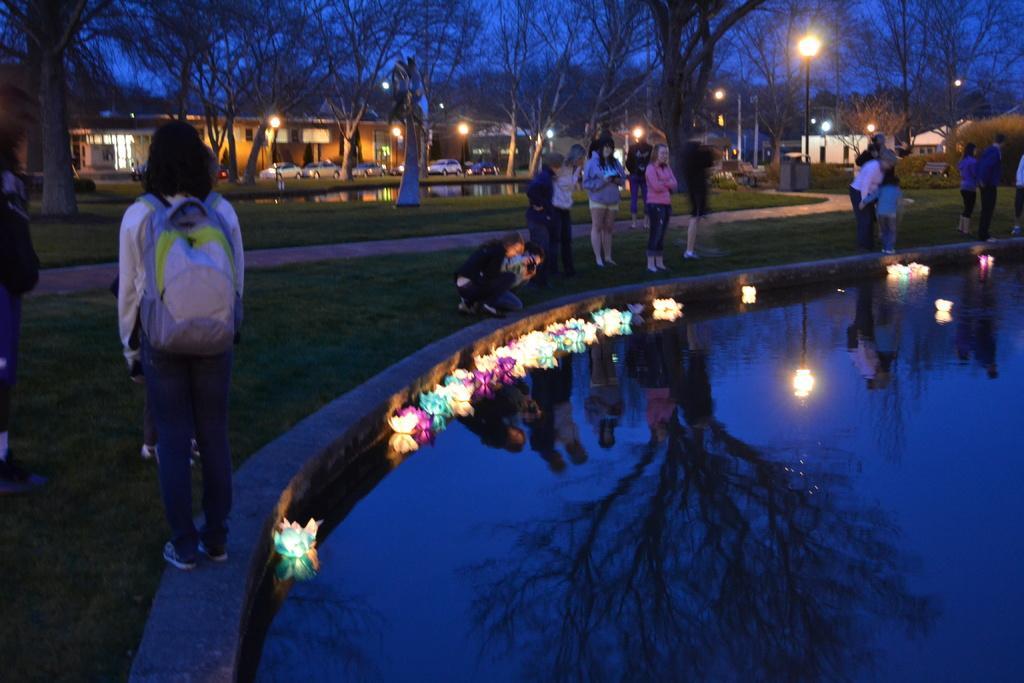Can you describe this image briefly? On the right side of the image there is water. On the water there are flowers with lights. And also there is a reflection of a tree and few people. Behind the water there is a small wall fencing. On the small wall there are few people standing. And on the ground there is grass and also there are few people standing on the ground. Behind them there are trees and water on the ground. Behind the trees there are buildings with walls, windows and roofs. And also there are poles with lamps. 